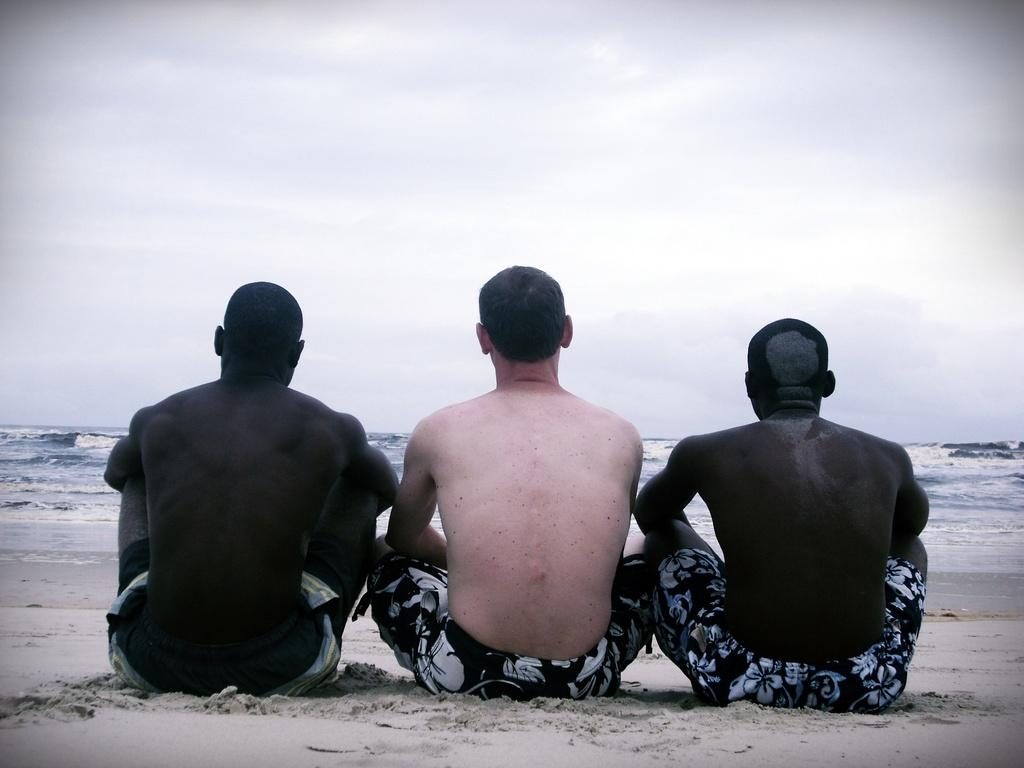How many people are in the image? There are three people in the image. What are the people doing in the image? The people are sitting on the sand. What can be seen in the background of the image? There is an ocean in the background of the image. What is the condition of the sky in the image? The sky is clear in the image. What type of bead is being used to create a crook in the image? There is no bead or crook present in the image. What channel is the ocean connected to in the image? The image does not show the ocean connected to any specific channel. 